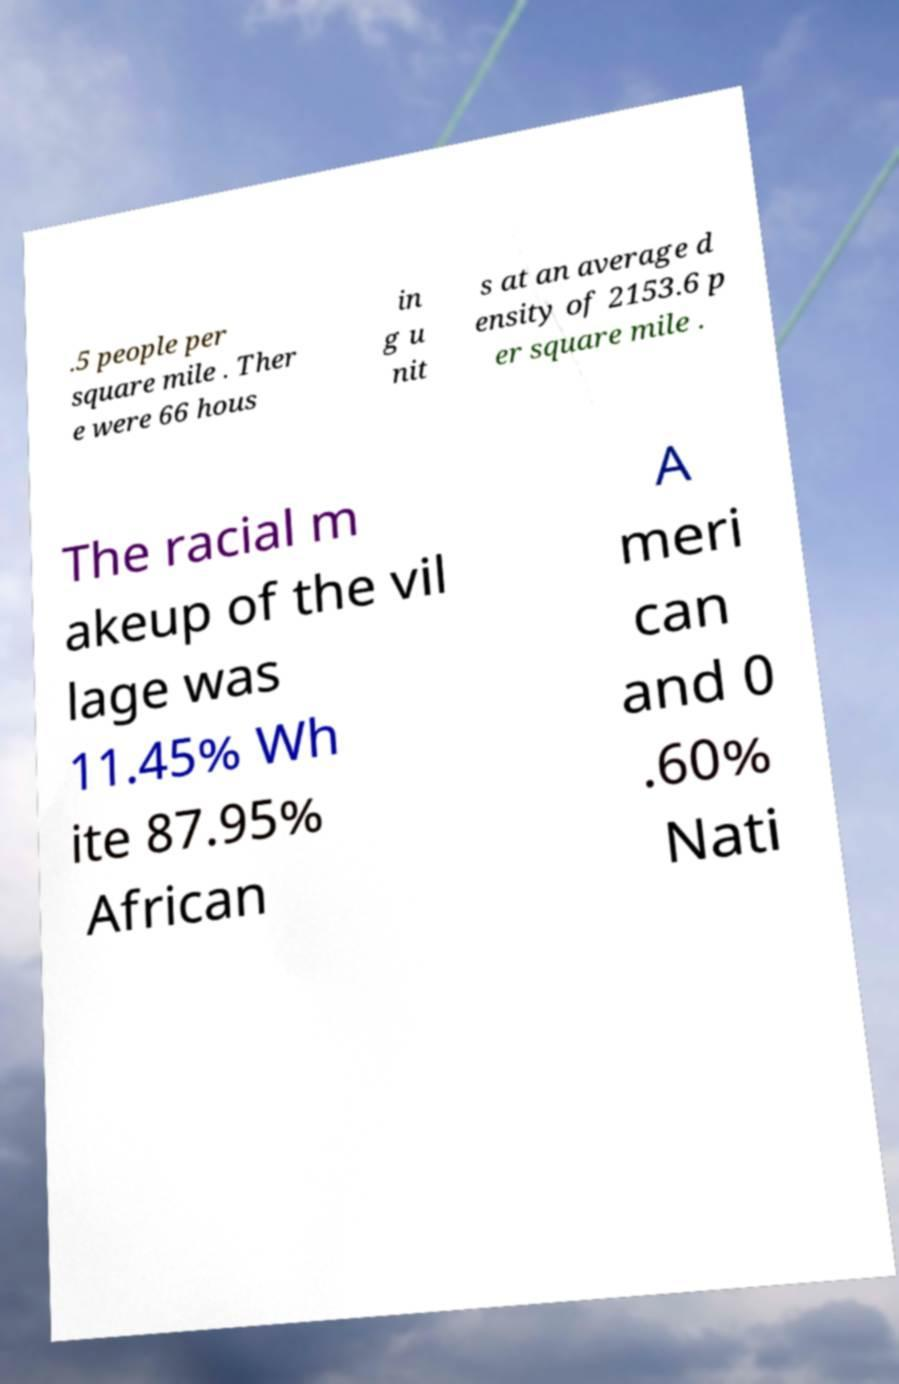Can you read and provide the text displayed in the image?This photo seems to have some interesting text. Can you extract and type it out for me? .5 people per square mile . Ther e were 66 hous in g u nit s at an average d ensity of 2153.6 p er square mile . The racial m akeup of the vil lage was 11.45% Wh ite 87.95% African A meri can and 0 .60% Nati 